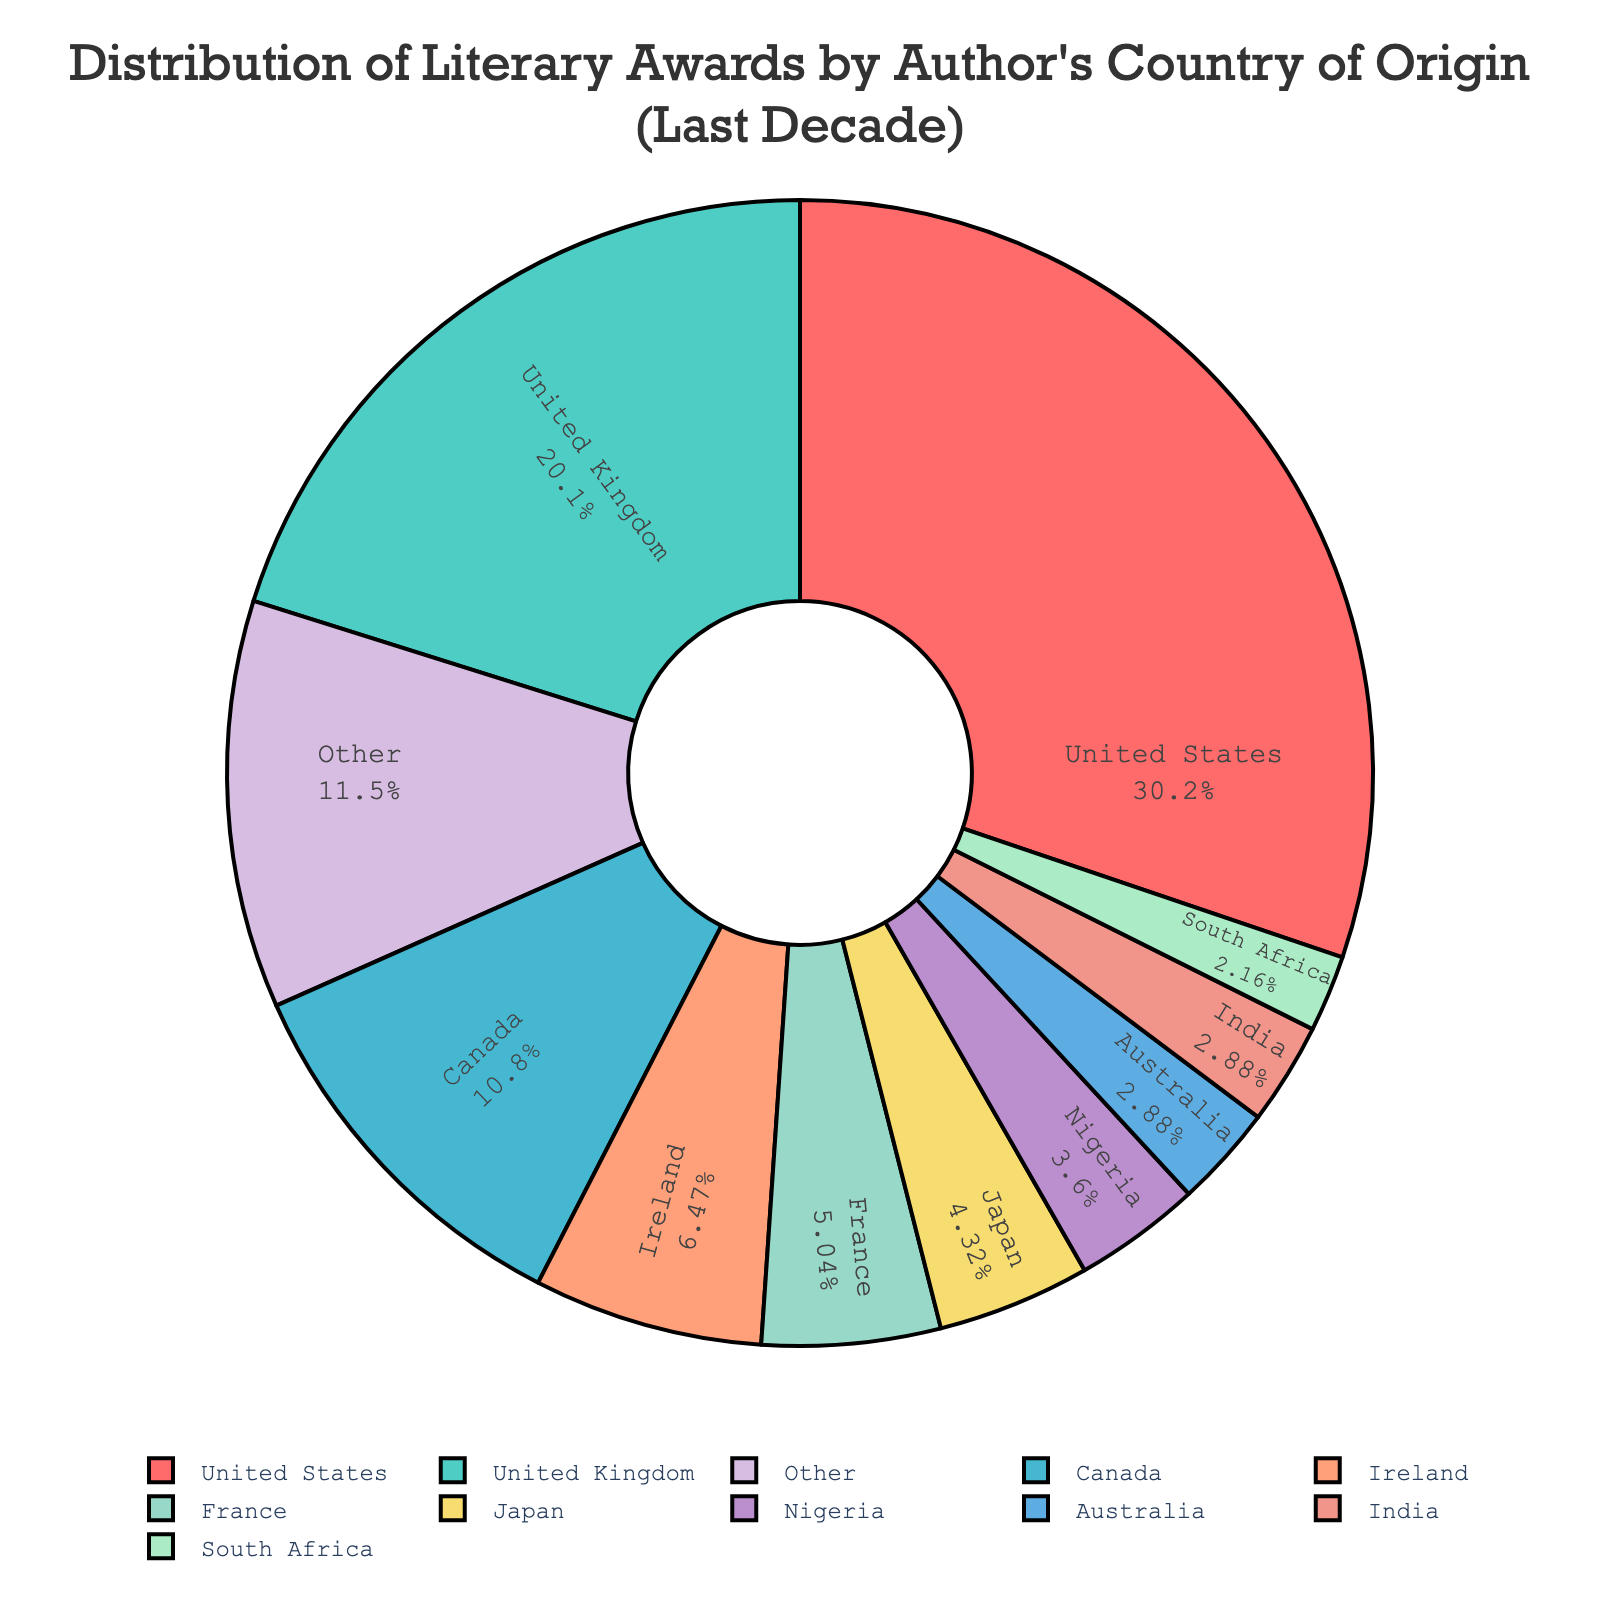Which country has the most literary awards? The pie chart shows the distribution with the largest segment representing the United States.
Answer: United States How many awards did the top-three countries combined receive? Sum the number of awards for the United States (42), the United Kingdom (28), and Canada (15). The total is 42 + 28 + 15 = 85.
Answer: 85 Which country received more awards, France or Japan? Compare the segments for France (7 awards) and Japan (6 awards). France has more awards.
Answer: France What's the percentage of awards received by Ireland? Look at the pie chart segment for Ireland, which is labeled with the percentage. It shows that Ireland received 9 awards out of a total of 42 + 28 + 15 + 9 + 7 + 6 + 5 + 4 + 4 + 3 + 3 + 2 + 2 + 2 + 2 + 1 + 1 + 1 + 1 + 1 = 139. The percentage is (9/139)*100 ≈ 6.5%.
Answer: Approximately 6.5% Which countries are represented by the same color? Check the segments of the pie chart and identify the sections sharing the same color. This should not appear in a well-designed pie chart as each country should have a unique color. Therefore, no countries share the same color.
Answer: None How do the total awards of the top 10 countries compare to the total of the other countries? Sum the awards for the top 10 countries: 42 (US) + 28 (UK) + 15 (Canada) + 9 (Ireland) + 7 (France) + 6 (Japan) + 5 (Nigeria) + 4 (Australia) + 4 (India) + 3 (Germany) = 123. Compare this to the total awards of the other countries combined, which is indicated by a single "Other" segment in the pie chart. The "Other" segment shows the sum of the remaining awards, which is 16.
Answer: Top 10: 123, Others: 16 By how many awards does the United States lead over the United Kingdom? The United States has 42 awards, and the United Kingdom has 28 awards. The difference is 42 - 28 = 14.
Answer: 14 Which section of the pie chart represents exactly two awards? Look for the segments labeled with "2" awards. The chart indicates Colombia, Italy, Poland, and Sweden each have 2 awards.
Answer: Colombia, Italy, Poland, Sweden What proportion of the pie chart is represented by the "Other" category? The chart segment labeled as "Other" shows the sum of the awards from countries not in the top 10. This is 16 out of a total of 139, which is (16/139) * 100 ≈ 11.5%.
Answer: Approximately 11.5% How does the number of awards for Nigeria compare to Australia and India combined? Nigeria received 5 awards. Australia and India received 4 awards each. The combined total for Australia and India is 4 + 4 = 8.
Answer: Nigeria: 5, Australia + India: 8 